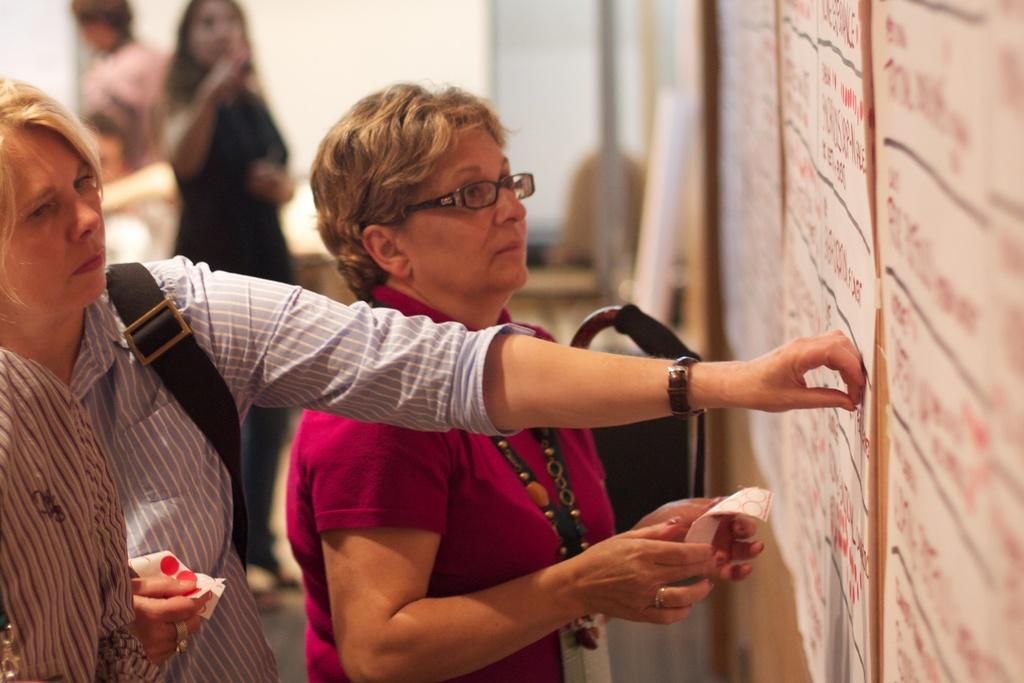Describe this image in one or two sentences. In this image I can see few persons are standing and holding few papers in their hands. In front of them I can see the wall and to it I can see few papers attached. I can see the blurry background in which I can see few other persons and the wall. 